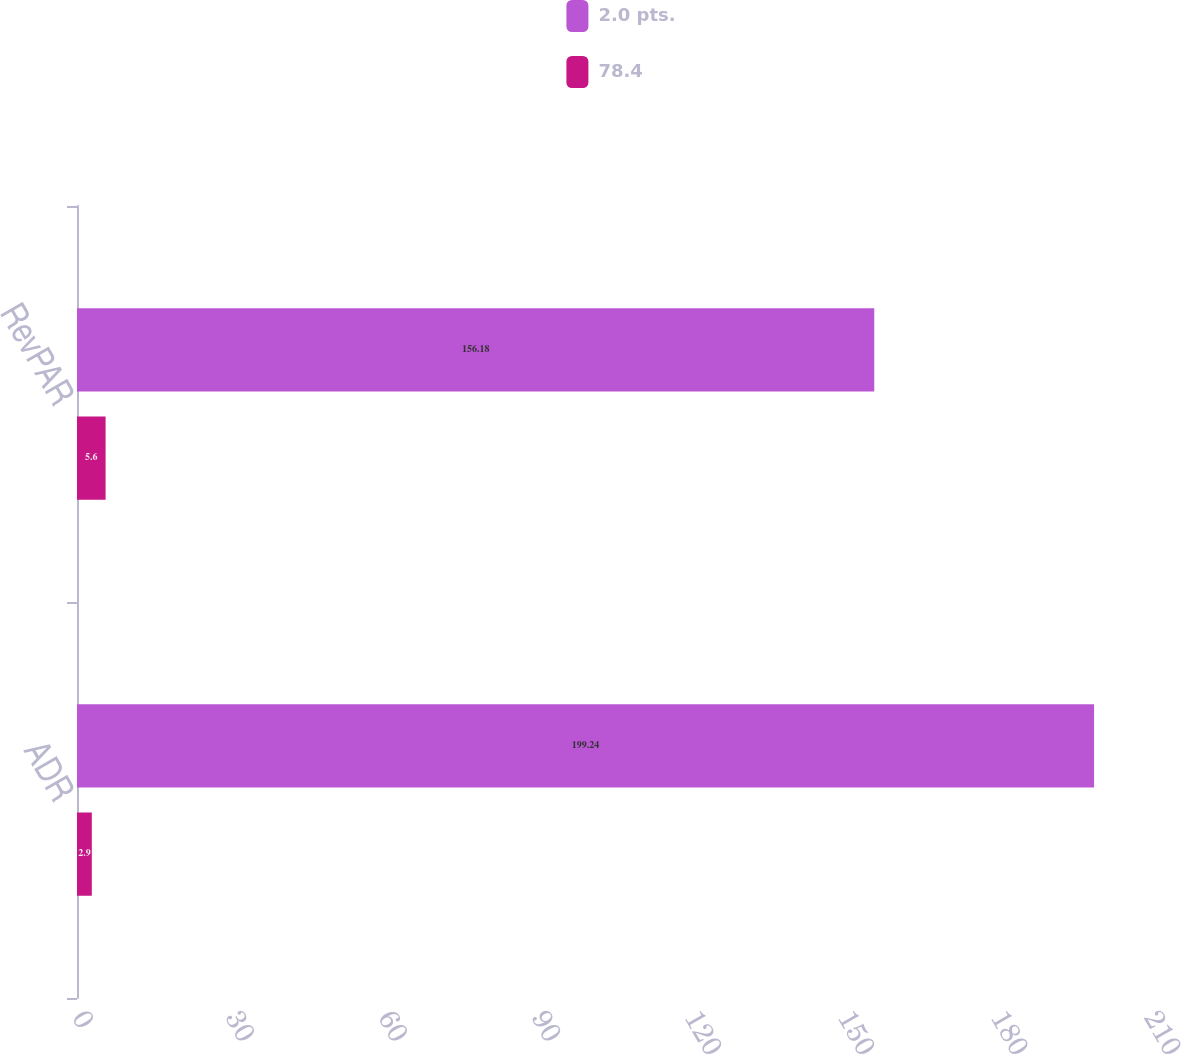Convert chart. <chart><loc_0><loc_0><loc_500><loc_500><stacked_bar_chart><ecel><fcel>ADR<fcel>RevPAR<nl><fcel>2.0 pts.<fcel>199.24<fcel>156.18<nl><fcel>78.4<fcel>2.9<fcel>5.6<nl></chart> 